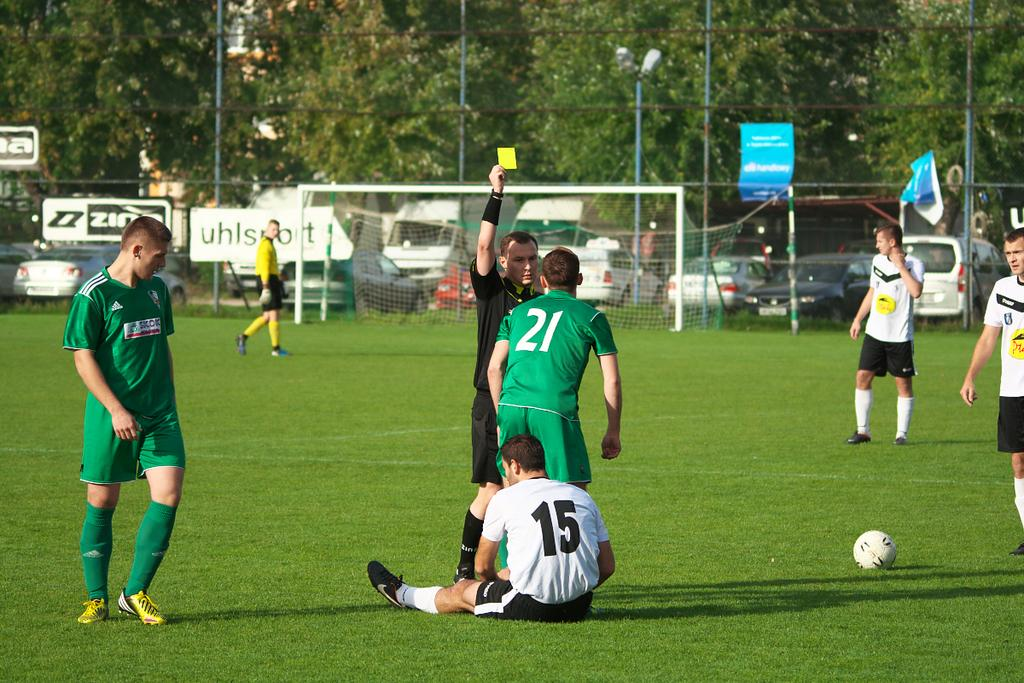Provide a one-sentence caption for the provided image. A soccer player whose number is 21 is being given a yellow card by the referee. 